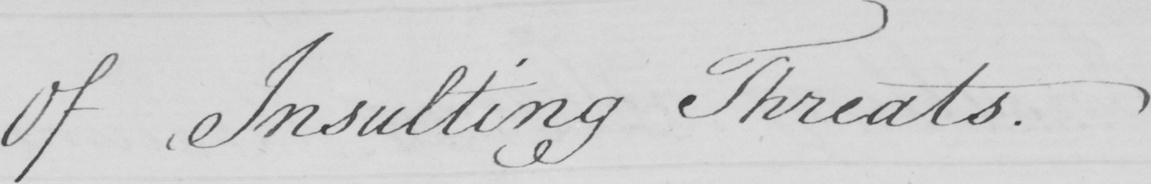What does this handwritten line say? Of Insulting Threats . 